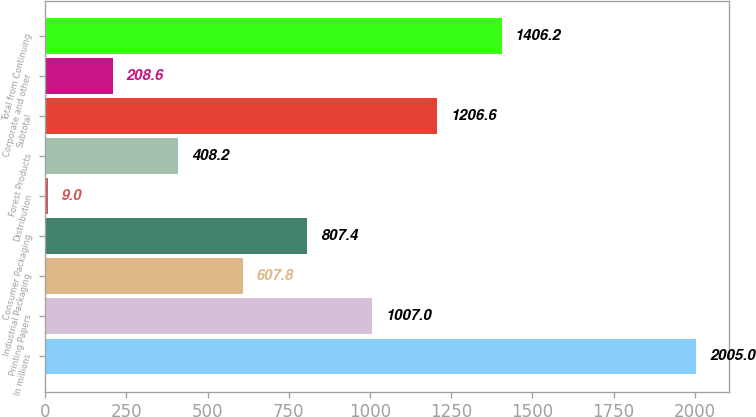Convert chart. <chart><loc_0><loc_0><loc_500><loc_500><bar_chart><fcel>In millions<fcel>Printing Papers<fcel>Industrial Packaging<fcel>Consumer Packaging<fcel>Distribution<fcel>Forest Products<fcel>Subtotal<fcel>Corporate and other<fcel>Total from Continuing<nl><fcel>2005<fcel>1007<fcel>607.8<fcel>807.4<fcel>9<fcel>408.2<fcel>1206.6<fcel>208.6<fcel>1406.2<nl></chart> 